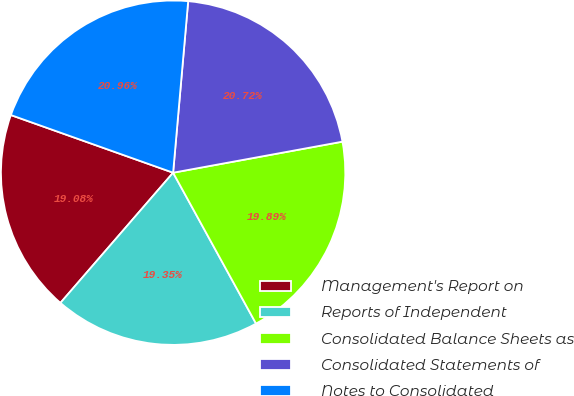Convert chart to OTSL. <chart><loc_0><loc_0><loc_500><loc_500><pie_chart><fcel>Management's Report on<fcel>Reports of Independent<fcel>Consolidated Balance Sheets as<fcel>Consolidated Statements of<fcel>Notes to Consolidated<nl><fcel>19.08%<fcel>19.35%<fcel>19.89%<fcel>20.72%<fcel>20.96%<nl></chart> 